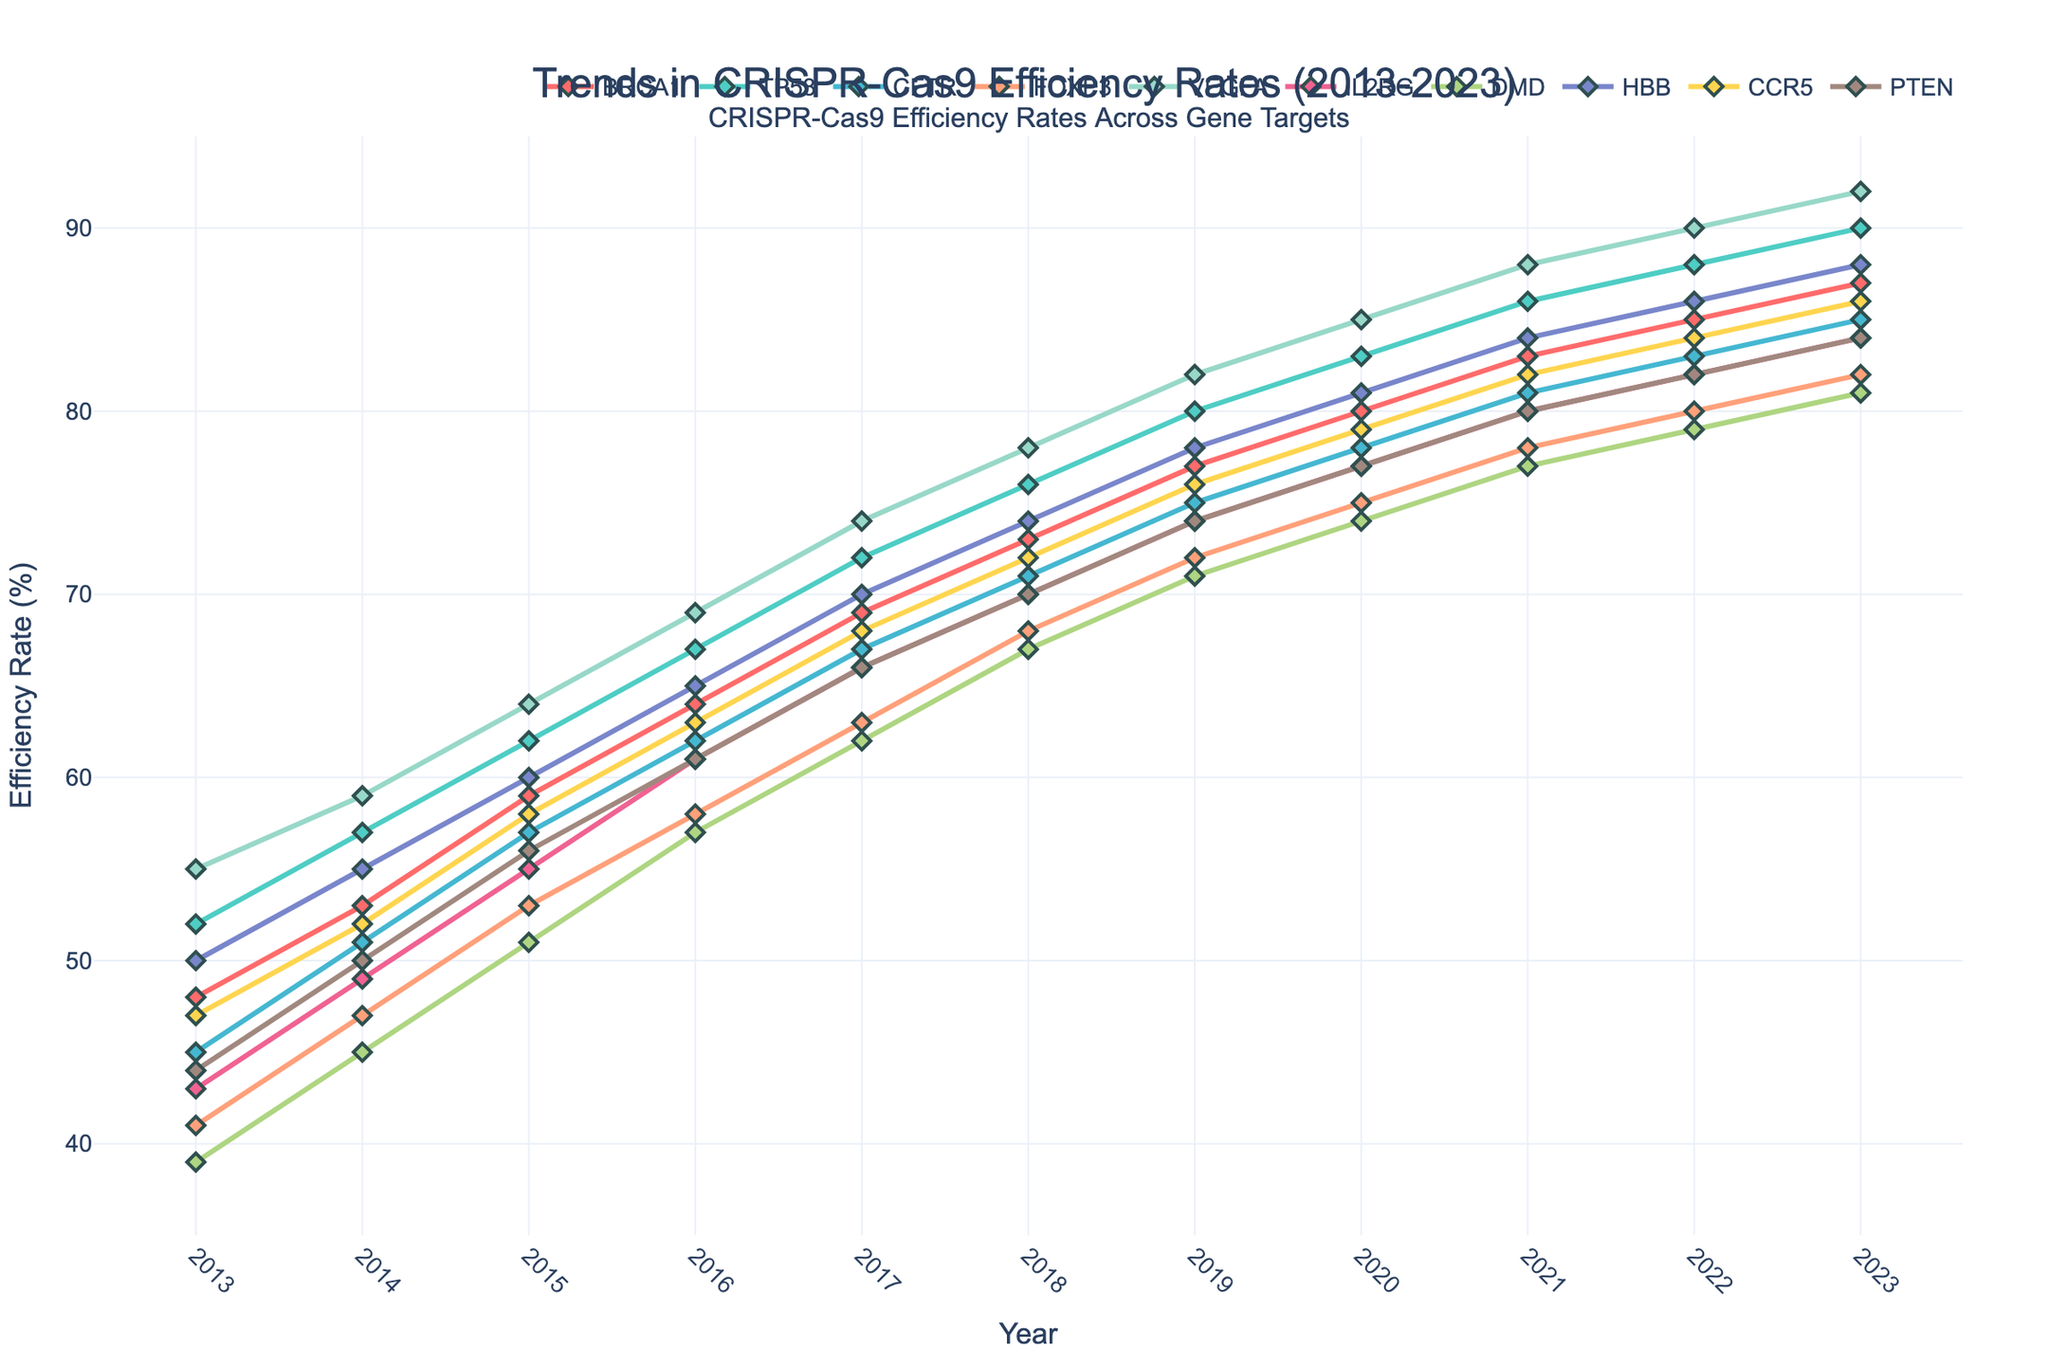Which gene had the highest CRISPR-Cas9 efficiency rate in 2023? To find the gene with the highest efficiency rate in 2023, look at the y-values for each gene and pick the highest one. VEGFA has the highest efficiency rate at 92% in 2023.
Answer: VEGFA Which gene showed the largest overall increase in efficiency rate from 2013 to 2023? Calculate the difference between the 2023 and 2013 values for each gene. VEGFA increased from 55% to 92%, a 37% increase, which is the largest.
Answer: VEGFA What is the average efficiency rate of BRCA1 from 2013 to 2023? Sum the efficiency rates of BRCA1 for each year from 2013 to 2023 and then divide by the number of years (11). The sum is 69 + 48 + 53 + 59 + 64 + 69 + 73 + 77 + 80 + 83 + 85 + 87 = 760, so the average is 760 / 11 ≈ 69.09.
Answer: 69.09 Which gene had the smallest efficiency rate increase between 2019 and 2021? Find the difference between the 2021 and 2019 values for each gene. IL2RG increased from 74% to 80%, an increase of 6%, which is the smallest.
Answer: IL2RG In which year did TP53 surpass a 70% efficiency rate? Find the first year where TP53’s efficiency rate exceeds 70%. This happens in 2016 with a rate of 72%.
Answer: 2017 Compare the efficiency rates of FOXP3 and DMD in 2018. Which one had a higher rate? Look at the efficiency rates for FOXP3 and DMD in 2018. FOXP3 has a rate of 68%, whereas DMD has a rate of 67%. So, FOXP3 is higher.
Answer: FOXP3 Which gene had the most consistent increase in efficiency rate over the years (2013-2023)? To determine consistency, observe the yearly increments. IL2RG increases at a consistent rate of about 6-8% each year.
Answer: IL2RG What was the difference in efficiency rates between BRCA1 and HBB in 2020? Look up the efficiency rates of BRCA1 and HBB in 2020, which are 80% and 81% respectively. The difference is 81% - 80% = 1%.
Answer: 1% In 2023, list the genes with an efficiency rate above 85%. Check the efficiency rates for 2023. The genes with rates above 85% are BRCA1, TP53, CFTR, VEGFA, and HBB.
Answer: BRCA1, TP53, CFTR, VEGFA, HBB What is the total efficiency rate sum for the genes TP53 and CCR5 across all years? Sum the efficiency rates for TP53 and CCR5 from 2013 to 2023. The sum for TP53 is 57 + 62 + 67 + 72 + 76 + 80 + 83 + 86 + 88 + 90 = 761, and for CCR5 it is 47 + 52 + 58 + 63 + 68 + 72 + 76 + 79 + 82 + 84 = 681. Total is 761 + 681 = 1442.
Answer: 1442 